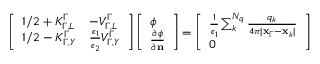Convert formula to latex. <formula><loc_0><loc_0><loc_500><loc_500>\begin{array} { r } { \left [ \begin{array} { l l } { 1 / 2 + K _ { \Gamma , L } ^ { \Gamma } } & { - V _ { \Gamma , L } ^ { \Gamma } } \\ { 1 / 2 - K _ { \Gamma , Y } ^ { \Gamma } } & { \frac { \epsilon _ { 1 } } { \epsilon _ { 2 } } V _ { \Gamma , Y } ^ { \Gamma } } \end{array} \right ] \left [ \begin{array} { l } { \phi } \\ { \frac { \partial \phi } { \partial n } } \end{array} \right ] = \left [ \begin{array} { l } { \frac { 1 } { \epsilon _ { 1 } } \sum _ { k } ^ { N _ { q } } \frac { q _ { k } } { 4 \pi | x _ { \Gamma } - x _ { k } | } } \\ { 0 } \end{array} \right ] } \end{array}</formula> 